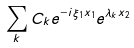<formula> <loc_0><loc_0><loc_500><loc_500>\sum _ { k } C _ { k } e ^ { - i \xi _ { 1 } x _ { 1 } } e ^ { \lambda _ { k } x _ { 2 } }</formula> 